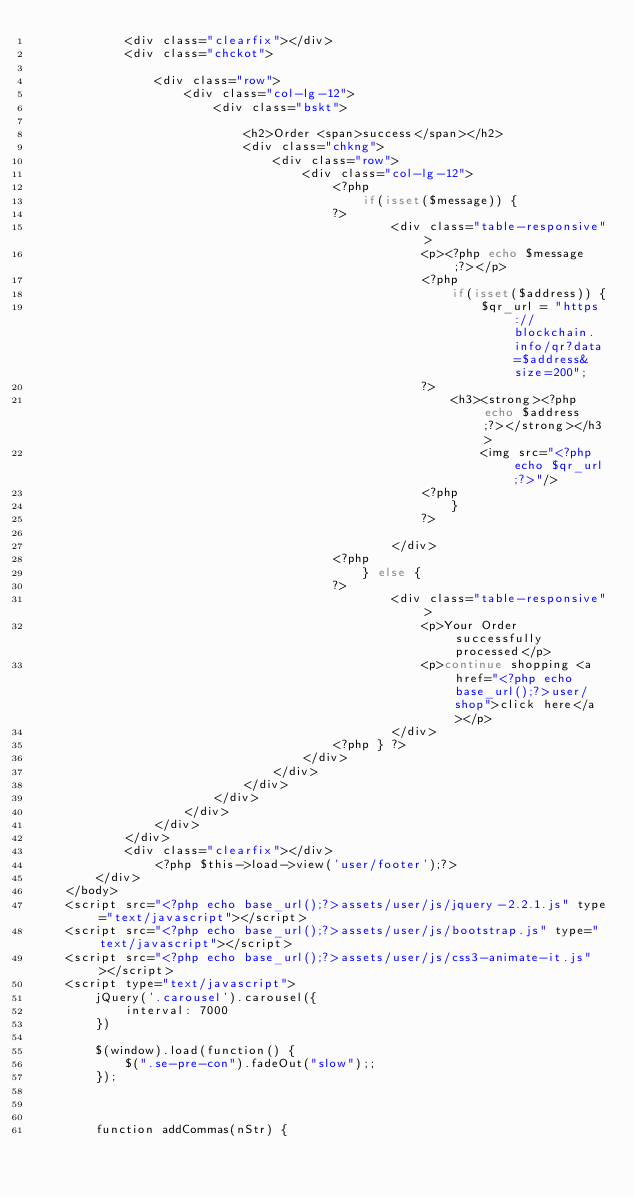<code> <loc_0><loc_0><loc_500><loc_500><_PHP_>			<div class="clearfix"></div>
			<div class="chckot">
				
				<div class="row">
					<div class="col-lg-12">
						<div class="bskt">
							
							<h2>Order <span>success</span></h2>
							<div class="chkng">
								<div class="row">
									<div class="col-lg-12">
										<?php 
											if(isset($message)) {
										?>
												<div class="table-responsive">
													<p><?php echo $message;?></p>
													<?php 
														if(isset($address)) {
															$qr_url = "https://blockchain.info/qr?data=$address&size=200";
													?>
														<h3><strong><?php echo $address;?></strong></h3>
															<img src="<?php echo $qr_url;?>"/>
													<?php
														}
													?>
													
												</div>
										<?php
											} else {
										?>
												<div class="table-responsive">
													<p>Your Order successfully processed</p>
													<p>continue shopping <a href="<?php echo base_url();?>user/shop">click here</a></p>
												</div>
										<?php } ?>
									</div>
								</div>
							</div>
						</div>
					</div>
				</div>
			</div>
			<div class="clearfix"></div>
				<?php $this->load->view('user/footer');?>
		</div>
	</body>
	<script src="<?php echo base_url();?>assets/user/js/jquery-2.2.1.js" type="text/javascript"></script>
	<script src="<?php echo base_url();?>assets/user/js/bootstrap.js" type="text/javascript"></script>
	<script src="<?php echo base_url();?>assets/user/js/css3-animate-it.js"></script>
	<script type="text/javascript">
		jQuery('.carousel').carousel({
			interval: 7000
		})
		
		$(window).load(function() {
			$(".se-pre-con").fadeOut("slow");;
		});
		
		

		function addCommas(nStr) {</code> 